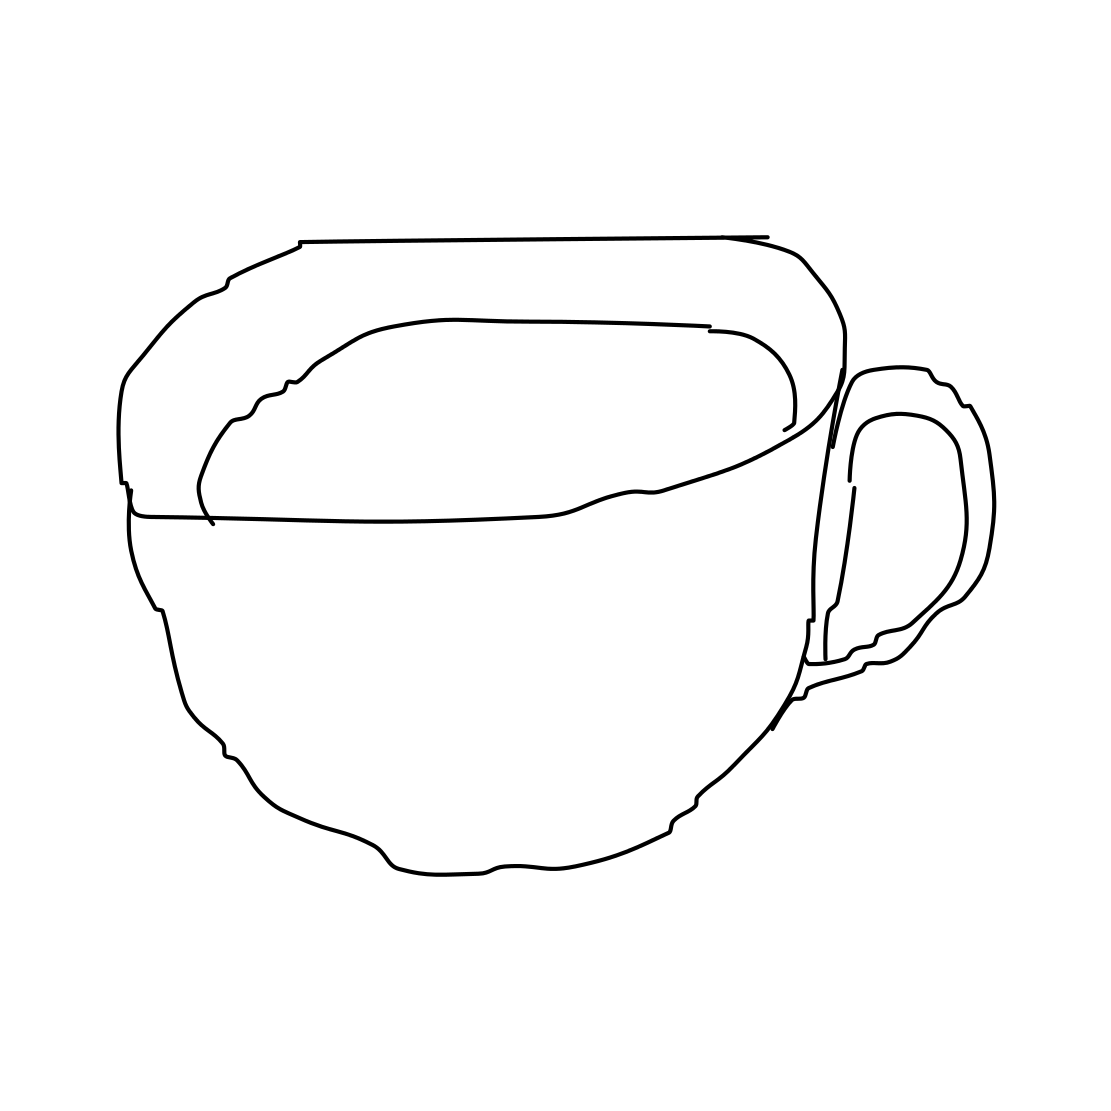Is this a cloud in the image? No, the image does not depict a cloud; it is a line drawing of a cup, likely used for drinking beverages such as coffee or tea. 